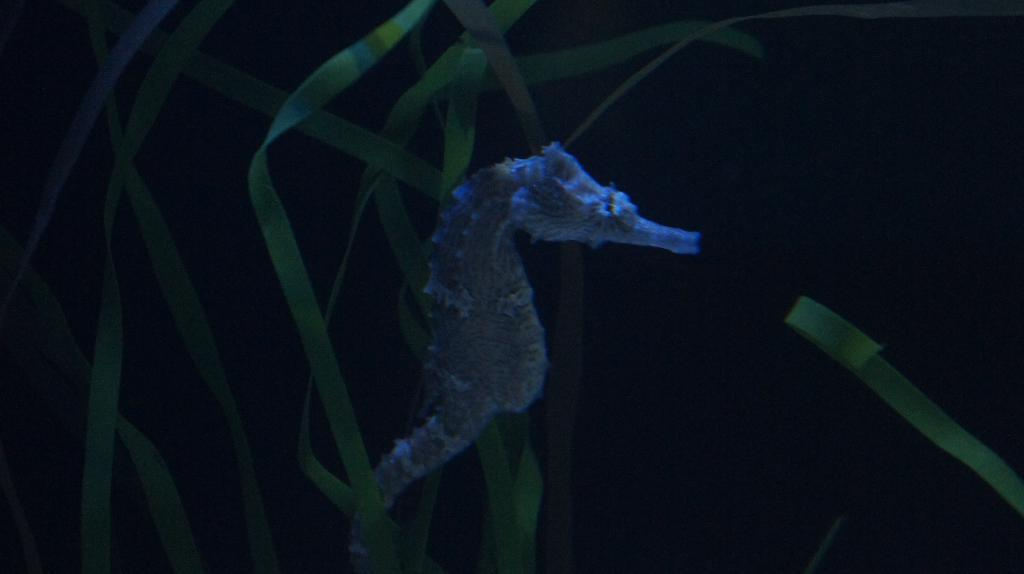What is the main subject in the foreground of the image? There is a seahorse in the foreground of the image. Where is the seahorse located in relation to the image? The seahorse is in the middle of the image. What can be seen in the background of the image? The background of the image is dark, and there are grass leaves visible in the background. What type of leather is being used to make a discovery in the image? There is no leather or discovery present in the image; it features a seahorse in the middle of a dark background with grass leaves visible. 